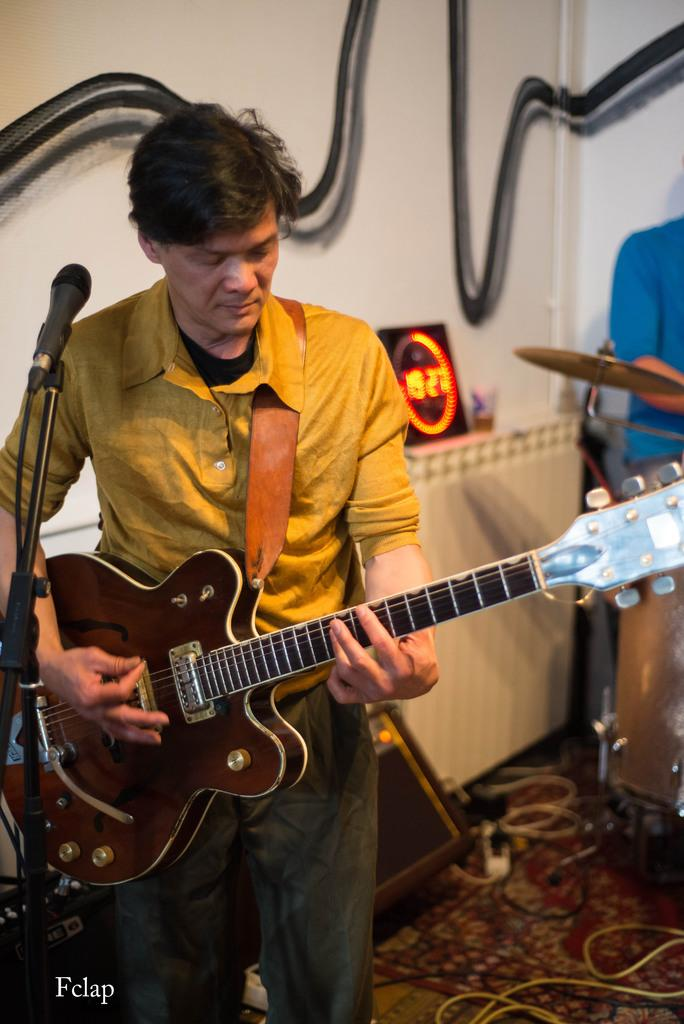What is the person in the image doing? The person is playing a guitar in the image. What object is present that is commonly used for amplifying sound? There is a microphone in the image. What other musical instrument can be seen in the image? There is a musical instrument in the image, but it is not specified which one. What can be seen in the background of the image? There is a wall in the background of the image. What type of fuel is being used by the crow in the image? There is no crow present in the image, and therefore no fuel is being used. 